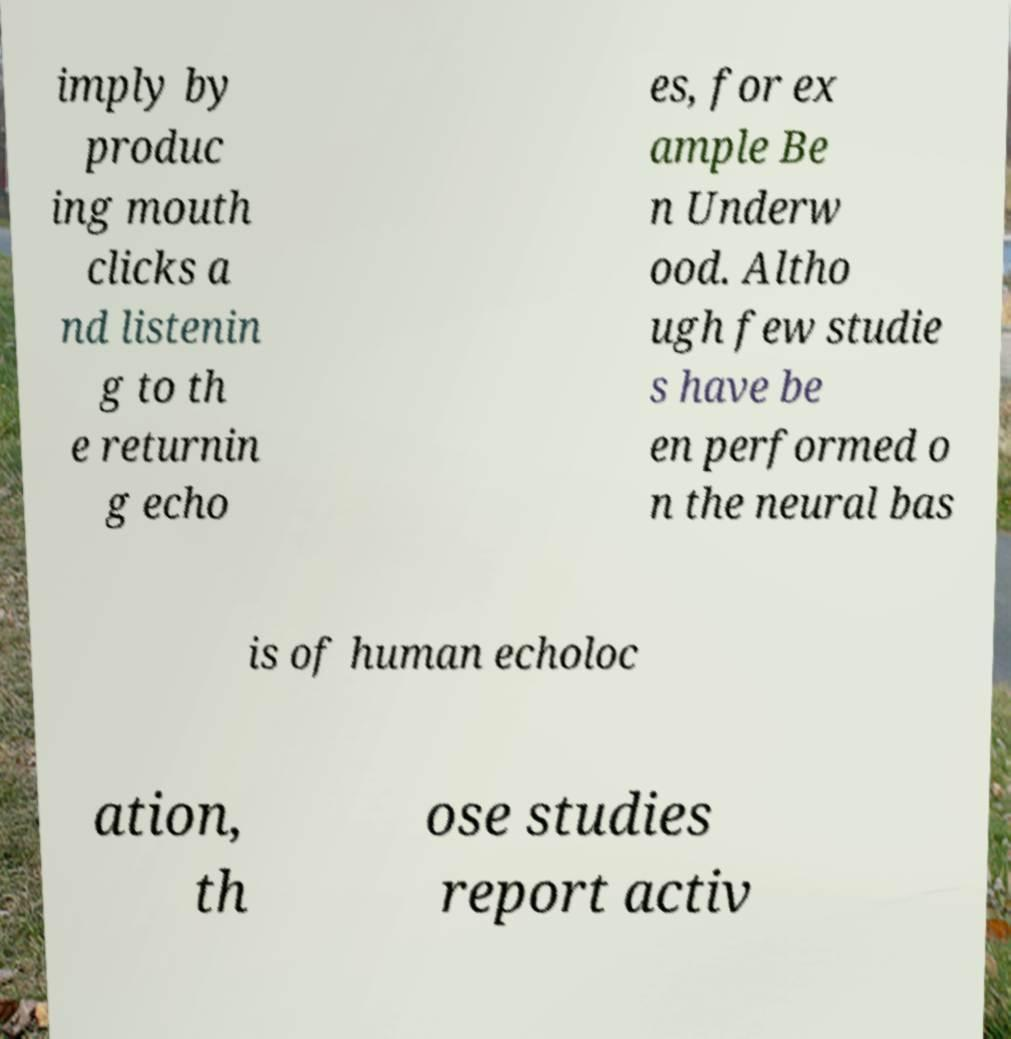For documentation purposes, I need the text within this image transcribed. Could you provide that? imply by produc ing mouth clicks a nd listenin g to th e returnin g echo es, for ex ample Be n Underw ood. Altho ugh few studie s have be en performed o n the neural bas is of human echoloc ation, th ose studies report activ 